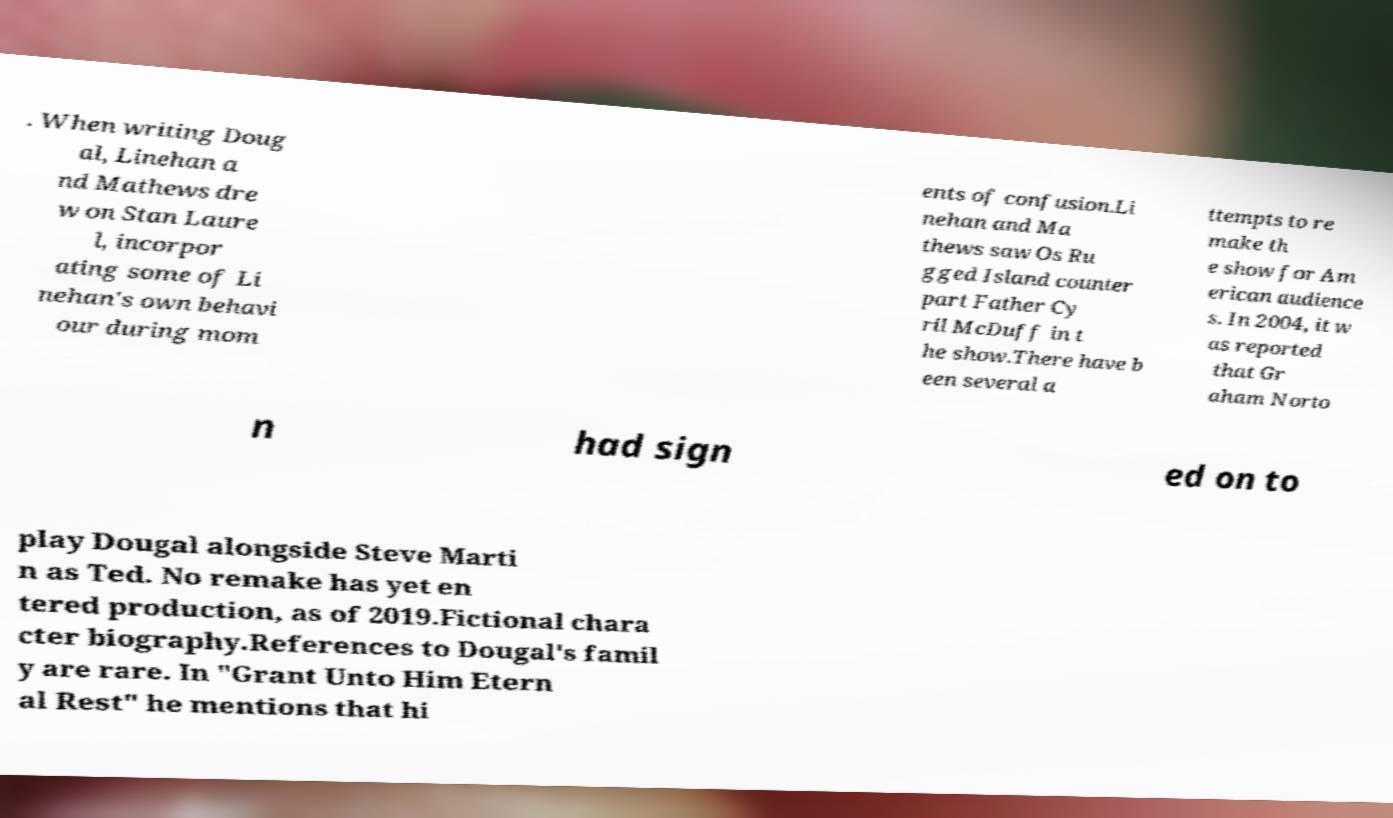Can you accurately transcribe the text from the provided image for me? . When writing Doug al, Linehan a nd Mathews dre w on Stan Laure l, incorpor ating some of Li nehan's own behavi our during mom ents of confusion.Li nehan and Ma thews saw Os Ru gged Island counter part Father Cy ril McDuff in t he show.There have b een several a ttempts to re make th e show for Am erican audience s. In 2004, it w as reported that Gr aham Norto n had sign ed on to play Dougal alongside Steve Marti n as Ted. No remake has yet en tered production, as of 2019.Fictional chara cter biography.References to Dougal's famil y are rare. In "Grant Unto Him Etern al Rest" he mentions that hi 